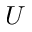<formula> <loc_0><loc_0><loc_500><loc_500>U</formula> 